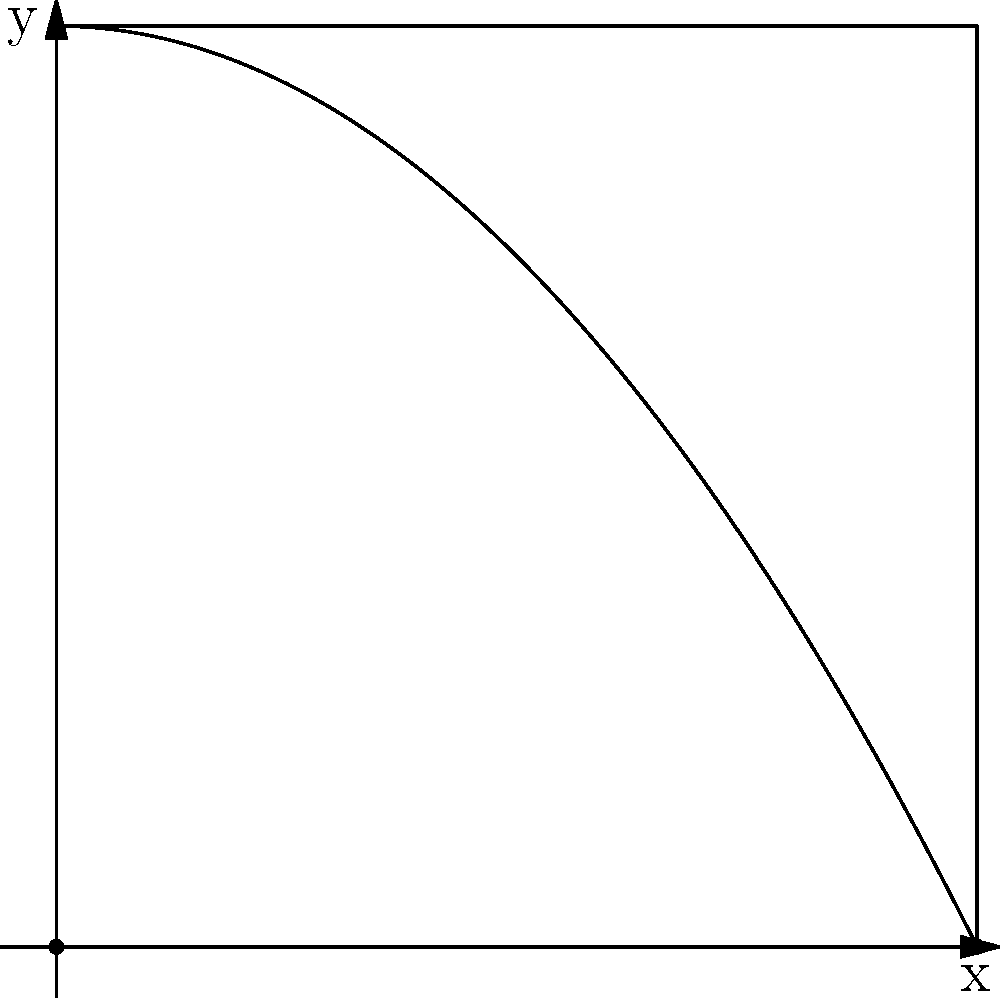In a mobile game, a character's jump trajectory is modeled by the function $f(x)=-\frac{x^2}{4}+4$ for $0 \leq x \leq 4$. Calculate the area under this curve to determine the character's total air time during the jump. To find the area under the curve, we'll use integration:

1) The area is given by the definite integral:
   $$A = \int_0^4 \left(-\frac{x^2}{4}+4\right) dx$$

2) Integrate the function:
   $$A = \left[-\frac{x^3}{12}+4x\right]_0^4$$

3) Evaluate the integral at the bounds:
   $$A = \left(-\frac{4^3}{12}+4(4)\right) - \left(-\frac{0^3}{12}+4(0)\right)$$

4) Simplify:
   $$A = \left(-\frac{64}{12}+16\right) - (0)$$
   $$A = -\frac{16}{3}+16$$
   $$A = 16-\frac{16}{3} = \frac{48}{3}-\frac{16}{3} = \frac{32}{3}$$

Therefore, the area under the curve is $\frac{32}{3}$ square units.
Answer: $\frac{32}{3}$ square units 